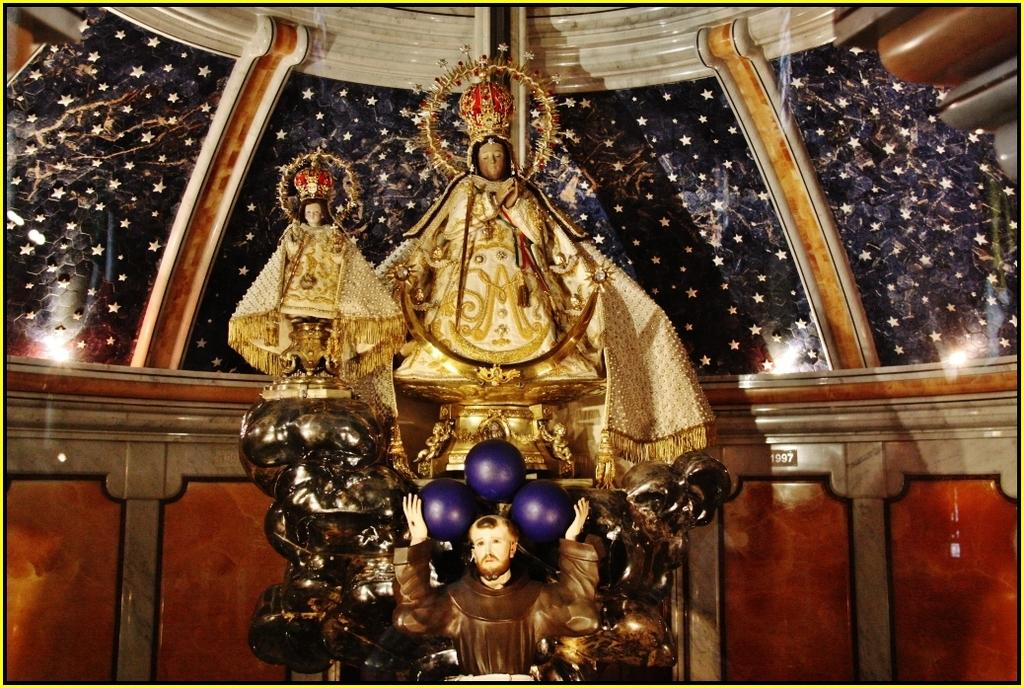What can be seen on pedestals in the image? There are statues on pedestals in the image. What distinguishing feature do the statues have? The statues have crowns. What can be seen in the background of the image? There are decorative walls in the background of the image. What is providing illumination in the image? There are lights visible in the image. What type of curtain can be seen hanging from the statue's arm in the image? There is no curtain present in the image, and no curtain is hanging from any statue's arm. Can you tell me how many babies are sitting on the statues in the image? There are no babies present in the image; the statues have crowns, not babies. 